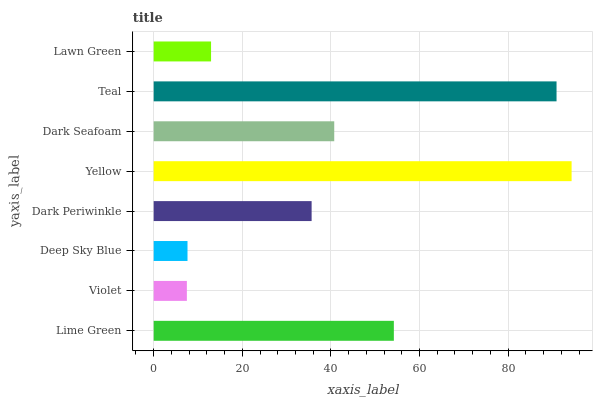Is Violet the minimum?
Answer yes or no. Yes. Is Yellow the maximum?
Answer yes or no. Yes. Is Deep Sky Blue the minimum?
Answer yes or no. No. Is Deep Sky Blue the maximum?
Answer yes or no. No. Is Deep Sky Blue greater than Violet?
Answer yes or no. Yes. Is Violet less than Deep Sky Blue?
Answer yes or no. Yes. Is Violet greater than Deep Sky Blue?
Answer yes or no. No. Is Deep Sky Blue less than Violet?
Answer yes or no. No. Is Dark Seafoam the high median?
Answer yes or no. Yes. Is Dark Periwinkle the low median?
Answer yes or no. Yes. Is Teal the high median?
Answer yes or no. No. Is Violet the low median?
Answer yes or no. No. 